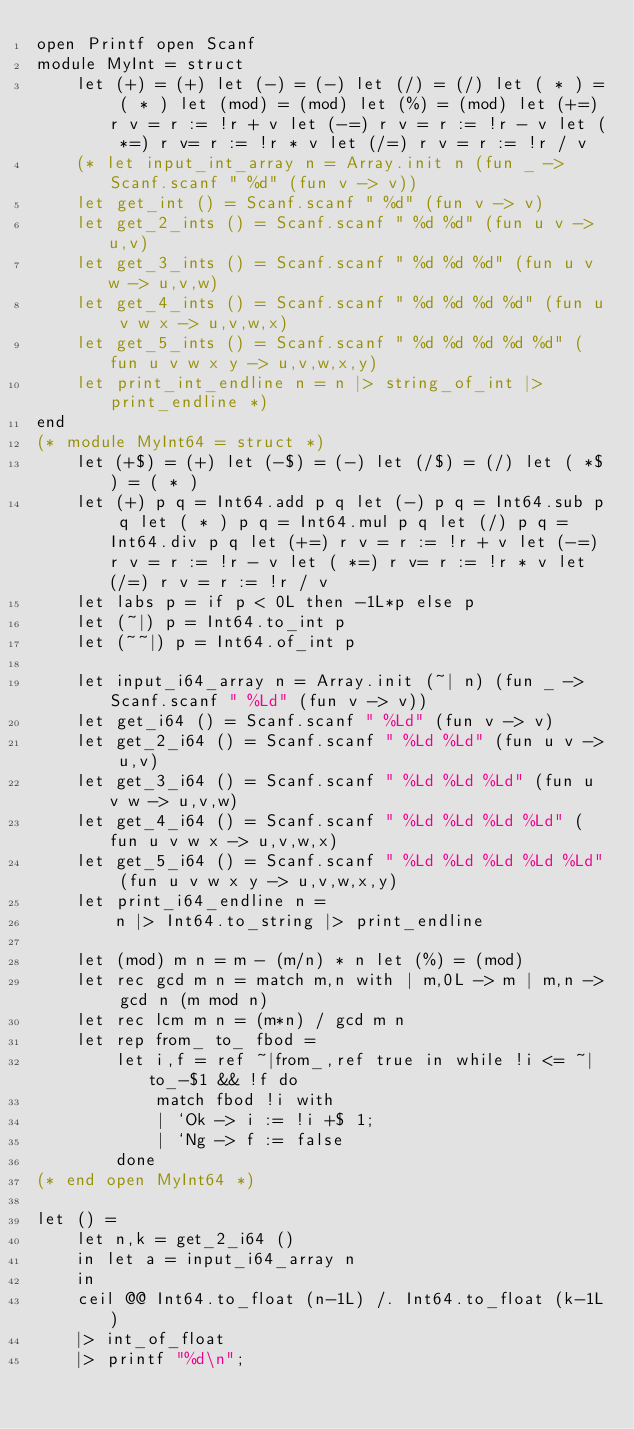Convert code to text. <code><loc_0><loc_0><loc_500><loc_500><_OCaml_>open Printf open Scanf
module MyInt = struct
	let (+) = (+) let (-) = (-) let (/) = (/) let ( * ) = ( * ) let (mod) = (mod) let (%) = (mod) let (+=) r v = r := !r + v let (-=) r v = r := !r - v let ( *=) r v= r := !r * v let (/=) r v = r := !r / v
	(* let input_int_array n = Array.init n (fun _ -> Scanf.scanf " %d" (fun v -> v))	
	let get_int () = Scanf.scanf " %d" (fun v -> v)
	let get_2_ints () = Scanf.scanf " %d %d" (fun u v -> u,v)
	let get_3_ints () = Scanf.scanf " %d %d %d" (fun u v w -> u,v,w)
	let get_4_ints () = Scanf.scanf " %d %d %d %d" (fun u v w x -> u,v,w,x)
	let get_5_ints () = Scanf.scanf " %d %d %d %d %d" (fun u v w x y -> u,v,w,x,y)
	let print_int_endline n = n |> string_of_int |> print_endline *)
end
(* module MyInt64 = struct *)
	let (+$) = (+) let (-$) = (-) let (/$) = (/) let ( *$) = ( * )
	let (+) p q = Int64.add p q let (-) p q = Int64.sub p q let ( * ) p q = Int64.mul p q let (/) p q = Int64.div p q let (+=) r v = r := !r + v let (-=) r v = r := !r - v let ( *=) r v= r := !r * v let (/=) r v = r := !r / v
	let labs p = if p < 0L then -1L*p else p
	let (~|) p = Int64.to_int p
	let (~~|) p = Int64.of_int p

	let input_i64_array n = Array.init (~| n) (fun _ -> Scanf.scanf " %Ld" (fun v -> v))
	let get_i64 () = Scanf.scanf " %Ld" (fun v -> v)
	let get_2_i64 () = Scanf.scanf " %Ld %Ld" (fun u v -> u,v)
	let get_3_i64 () = Scanf.scanf " %Ld %Ld %Ld" (fun u v w -> u,v,w)
	let get_4_i64 () = Scanf.scanf " %Ld %Ld %Ld %Ld" (fun u v w x -> u,v,w,x)
	let get_5_i64 () = Scanf.scanf " %Ld %Ld %Ld %Ld %Ld" (fun u v w x y -> u,v,w,x,y)
	let print_i64_endline n =
		n |> Int64.to_string |> print_endline
	
	let (mod) m n = m - (m/n) * n let (%) = (mod)
	let rec gcd m n = match m,n with | m,0L -> m | m,n -> gcd n (m mod n)
	let rec lcm m n = (m*n) / gcd m n
	let rep from_ to_ fbod =
		let i,f = ref ~|from_,ref true in while !i <= ~|to_-$1 && !f do
			match fbod !i with
			| `Ok -> i := !i +$ 1;
			| `Ng -> f := false
		done
(* end open MyInt64 *)

let () =
	let n,k = get_2_i64 ()
	in let a = input_i64_array n
	in
	ceil @@ Int64.to_float (n-1L) /. Int64.to_float (k-1L)
	|> int_of_float
	|> printf "%d\n";</code> 